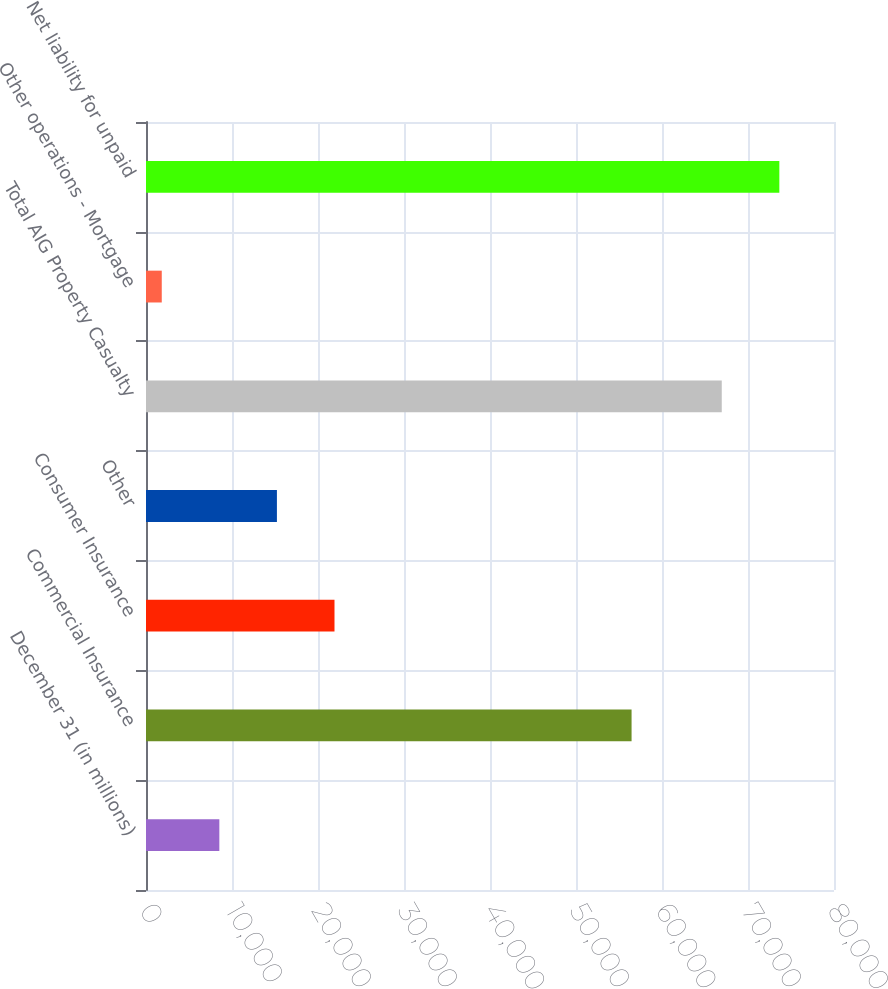Convert chart. <chart><loc_0><loc_0><loc_500><loc_500><bar_chart><fcel>December 31 (in millions)<fcel>Commercial Insurance<fcel>Consumer Insurance<fcel>Other<fcel>Total AIG Property Casualty<fcel>Other operations - Mortgage<fcel>Net liability for unpaid<nl><fcel>8527.9<fcel>56462<fcel>21917.7<fcel>15222.8<fcel>66949<fcel>1833<fcel>73643.9<nl></chart> 